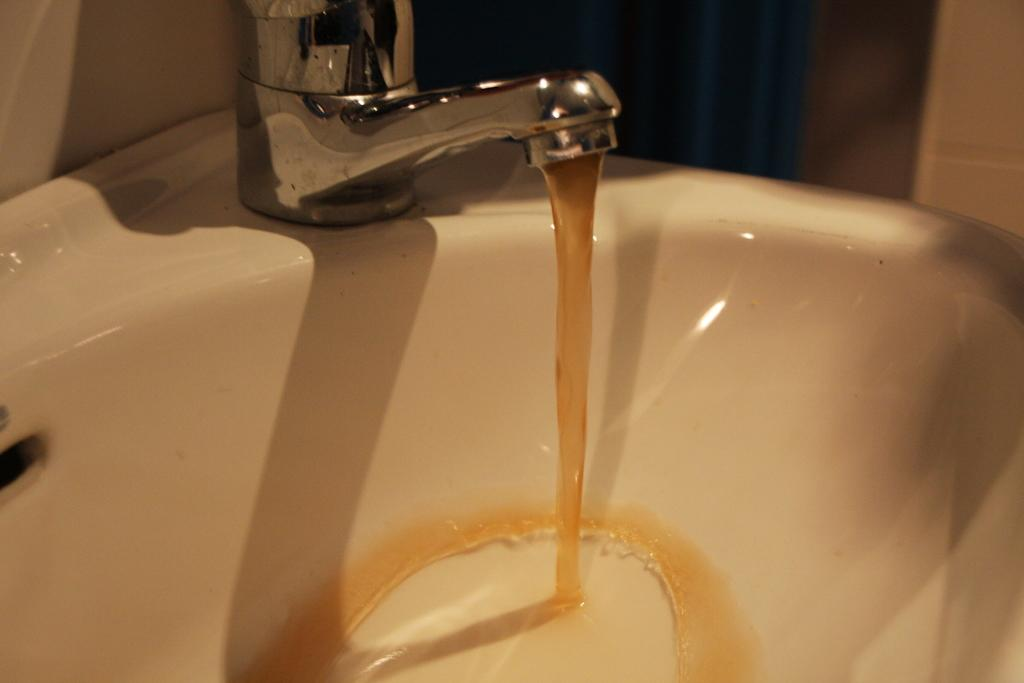What can be seen in the image related to washing or cleaning? There is a wash basin in the image. What feature does the wash basin have? The wash basin has a tap. What color is the water coming from the tap? Brown-colored water is coming from the tap. How many spiders are crawling on the wash basin in the image? There are no spiders present in the image. What type of pain is being experienced by the wash basin in the image? The wash basin is an inanimate object and cannot experience pain. 